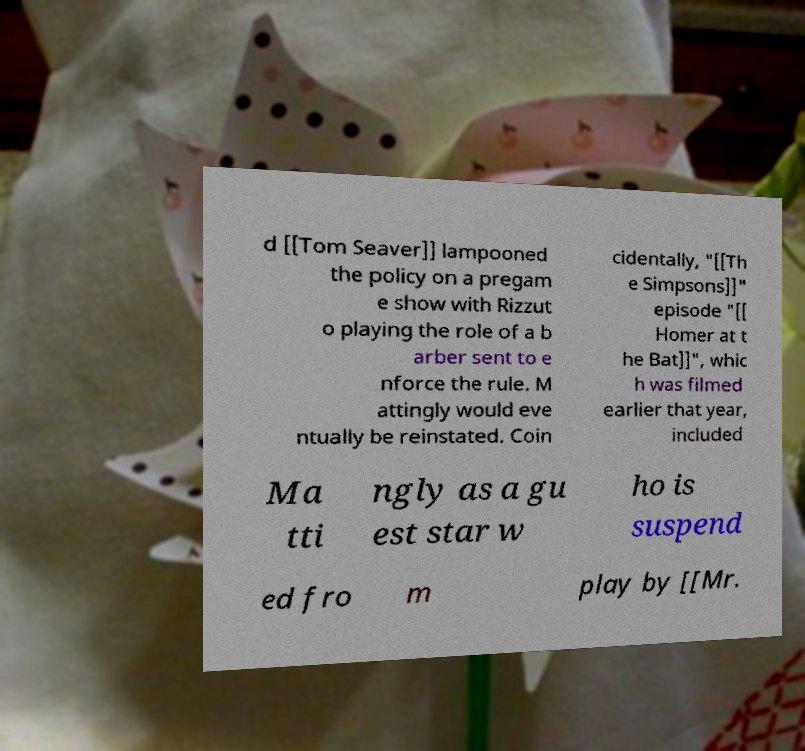Could you assist in decoding the text presented in this image and type it out clearly? d [[Tom Seaver]] lampooned the policy on a pregam e show with Rizzut o playing the role of a b arber sent to e nforce the rule. M attingly would eve ntually be reinstated. Coin cidentally, "[[Th e Simpsons]]" episode "[[ Homer at t he Bat]]", whic h was filmed earlier that year, included Ma tti ngly as a gu est star w ho is suspend ed fro m play by [[Mr. 